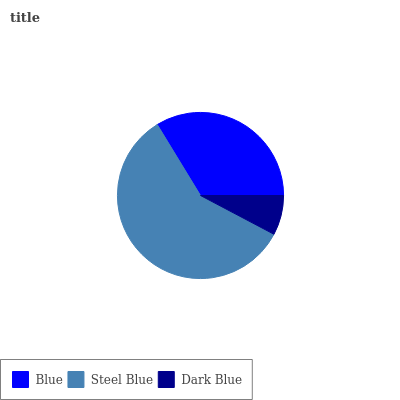Is Dark Blue the minimum?
Answer yes or no. Yes. Is Steel Blue the maximum?
Answer yes or no. Yes. Is Steel Blue the minimum?
Answer yes or no. No. Is Dark Blue the maximum?
Answer yes or no. No. Is Steel Blue greater than Dark Blue?
Answer yes or no. Yes. Is Dark Blue less than Steel Blue?
Answer yes or no. Yes. Is Dark Blue greater than Steel Blue?
Answer yes or no. No. Is Steel Blue less than Dark Blue?
Answer yes or no. No. Is Blue the high median?
Answer yes or no. Yes. Is Blue the low median?
Answer yes or no. Yes. Is Steel Blue the high median?
Answer yes or no. No. Is Dark Blue the low median?
Answer yes or no. No. 